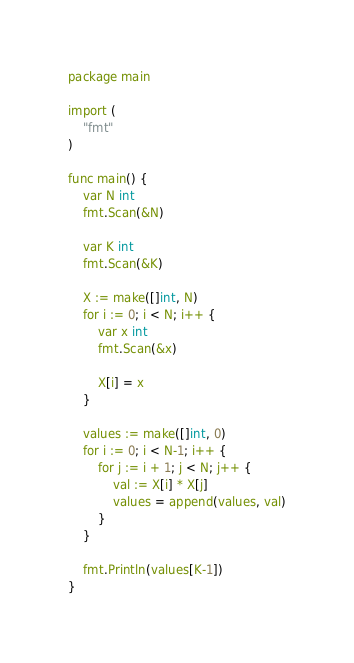Convert code to text. <code><loc_0><loc_0><loc_500><loc_500><_Go_>package main

import (
	"fmt"
)

func main() {
	var N int
	fmt.Scan(&N)

	var K int
	fmt.Scan(&K)

	X := make([]int, N)
	for i := 0; i < N; i++ {
		var x int
		fmt.Scan(&x)

		X[i] = x
	}

	values := make([]int, 0)
	for i := 0; i < N-1; i++ {
		for j := i + 1; j < N; j++ {
			val := X[i] * X[j]
			values = append(values, val)
		}
	}

	fmt.Println(values[K-1])
}
</code> 